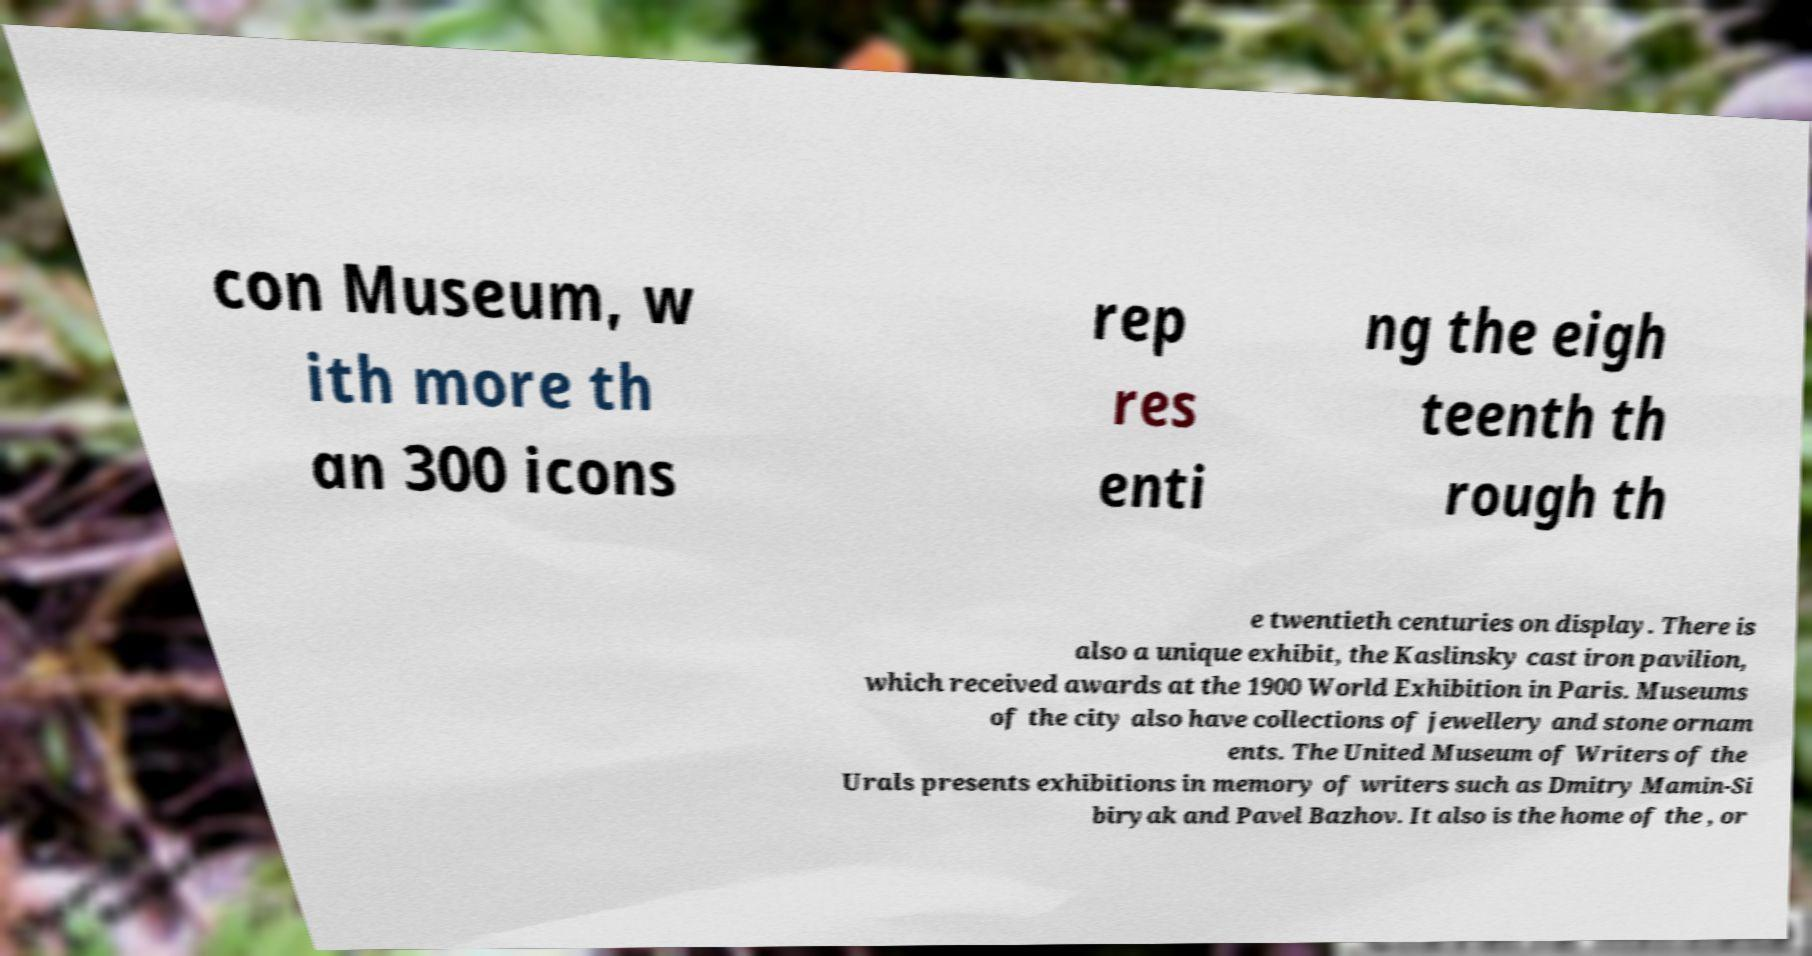Please identify and transcribe the text found in this image. con Museum, w ith more th an 300 icons rep res enti ng the eigh teenth th rough th e twentieth centuries on display. There is also a unique exhibit, the Kaslinsky cast iron pavilion, which received awards at the 1900 World Exhibition in Paris. Museums of the city also have collections of jewellery and stone ornam ents. The United Museum of Writers of the Urals presents exhibitions in memory of writers such as Dmitry Mamin-Si biryak and Pavel Bazhov. It also is the home of the , or 